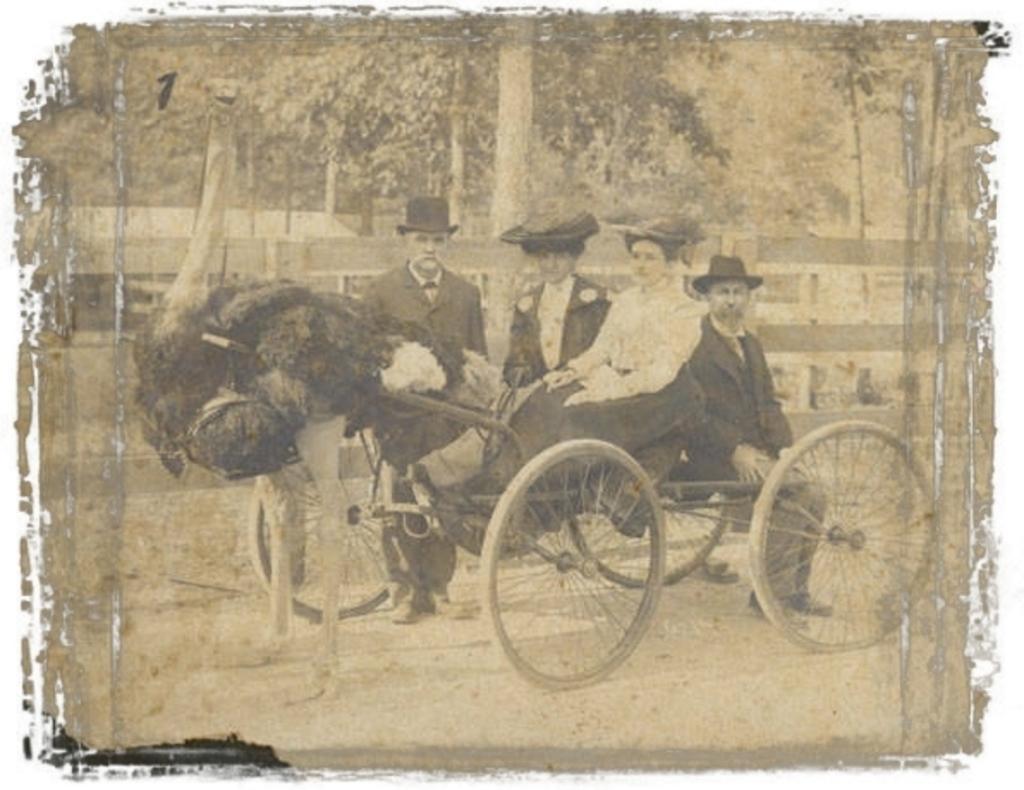Describe this image in one or two sentences. In the foreground of the picture I can see four persons sitting in the cart and there is a bird on the left side. In the background, I can see the trees. 